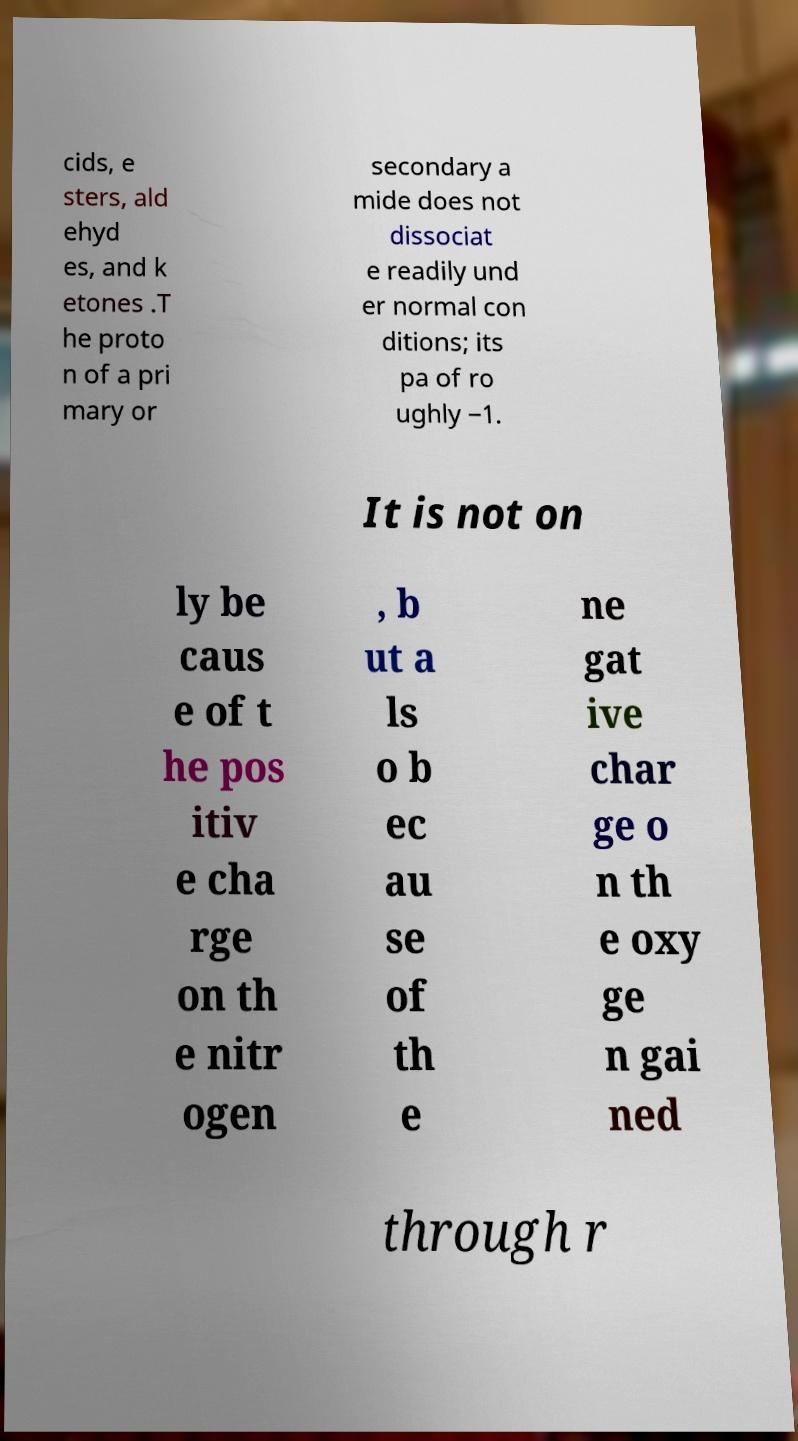Please identify and transcribe the text found in this image. cids, e sters, ald ehyd es, and k etones .T he proto n of a pri mary or secondary a mide does not dissociat e readily und er normal con ditions; its pa of ro ughly −1. It is not on ly be caus e of t he pos itiv e cha rge on th e nitr ogen , b ut a ls o b ec au se of th e ne gat ive char ge o n th e oxy ge n gai ned through r 